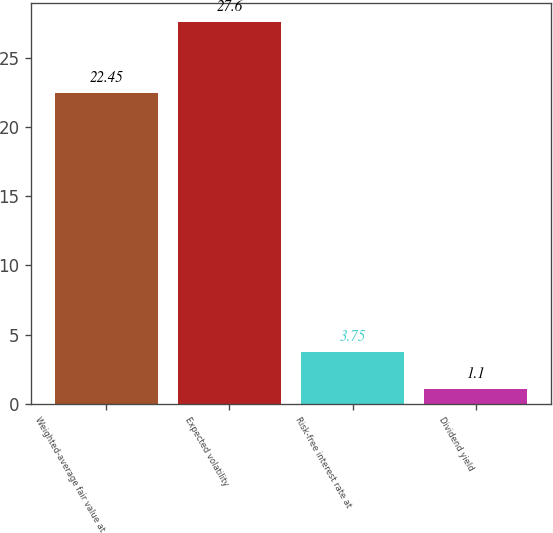Convert chart to OTSL. <chart><loc_0><loc_0><loc_500><loc_500><bar_chart><fcel>Weighted-average fair value at<fcel>Expected volatility<fcel>Risk-free interest rate at<fcel>Dividend yield<nl><fcel>22.45<fcel>27.6<fcel>3.75<fcel>1.1<nl></chart> 